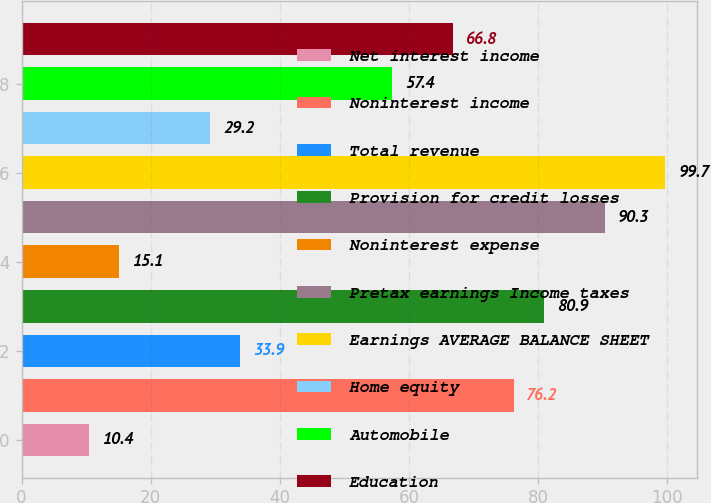Convert chart to OTSL. <chart><loc_0><loc_0><loc_500><loc_500><bar_chart><fcel>Net interest income<fcel>Noninterest income<fcel>Total revenue<fcel>Provision for credit losses<fcel>Noninterest expense<fcel>Pretax earnings Income taxes<fcel>Earnings AVERAGE BALANCE SHEET<fcel>Home equity<fcel>Automobile<fcel>Education<nl><fcel>10.4<fcel>76.2<fcel>33.9<fcel>80.9<fcel>15.1<fcel>90.3<fcel>99.7<fcel>29.2<fcel>57.4<fcel>66.8<nl></chart> 